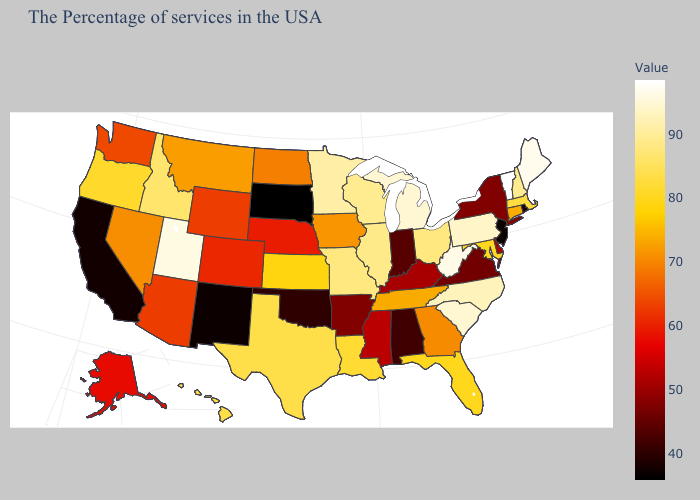Is the legend a continuous bar?
Write a very short answer. Yes. Does Idaho have a higher value than Washington?
Quick response, please. Yes. Which states hav the highest value in the Northeast?
Write a very short answer. Vermont. Does Montana have a lower value than Idaho?
Answer briefly. Yes. 